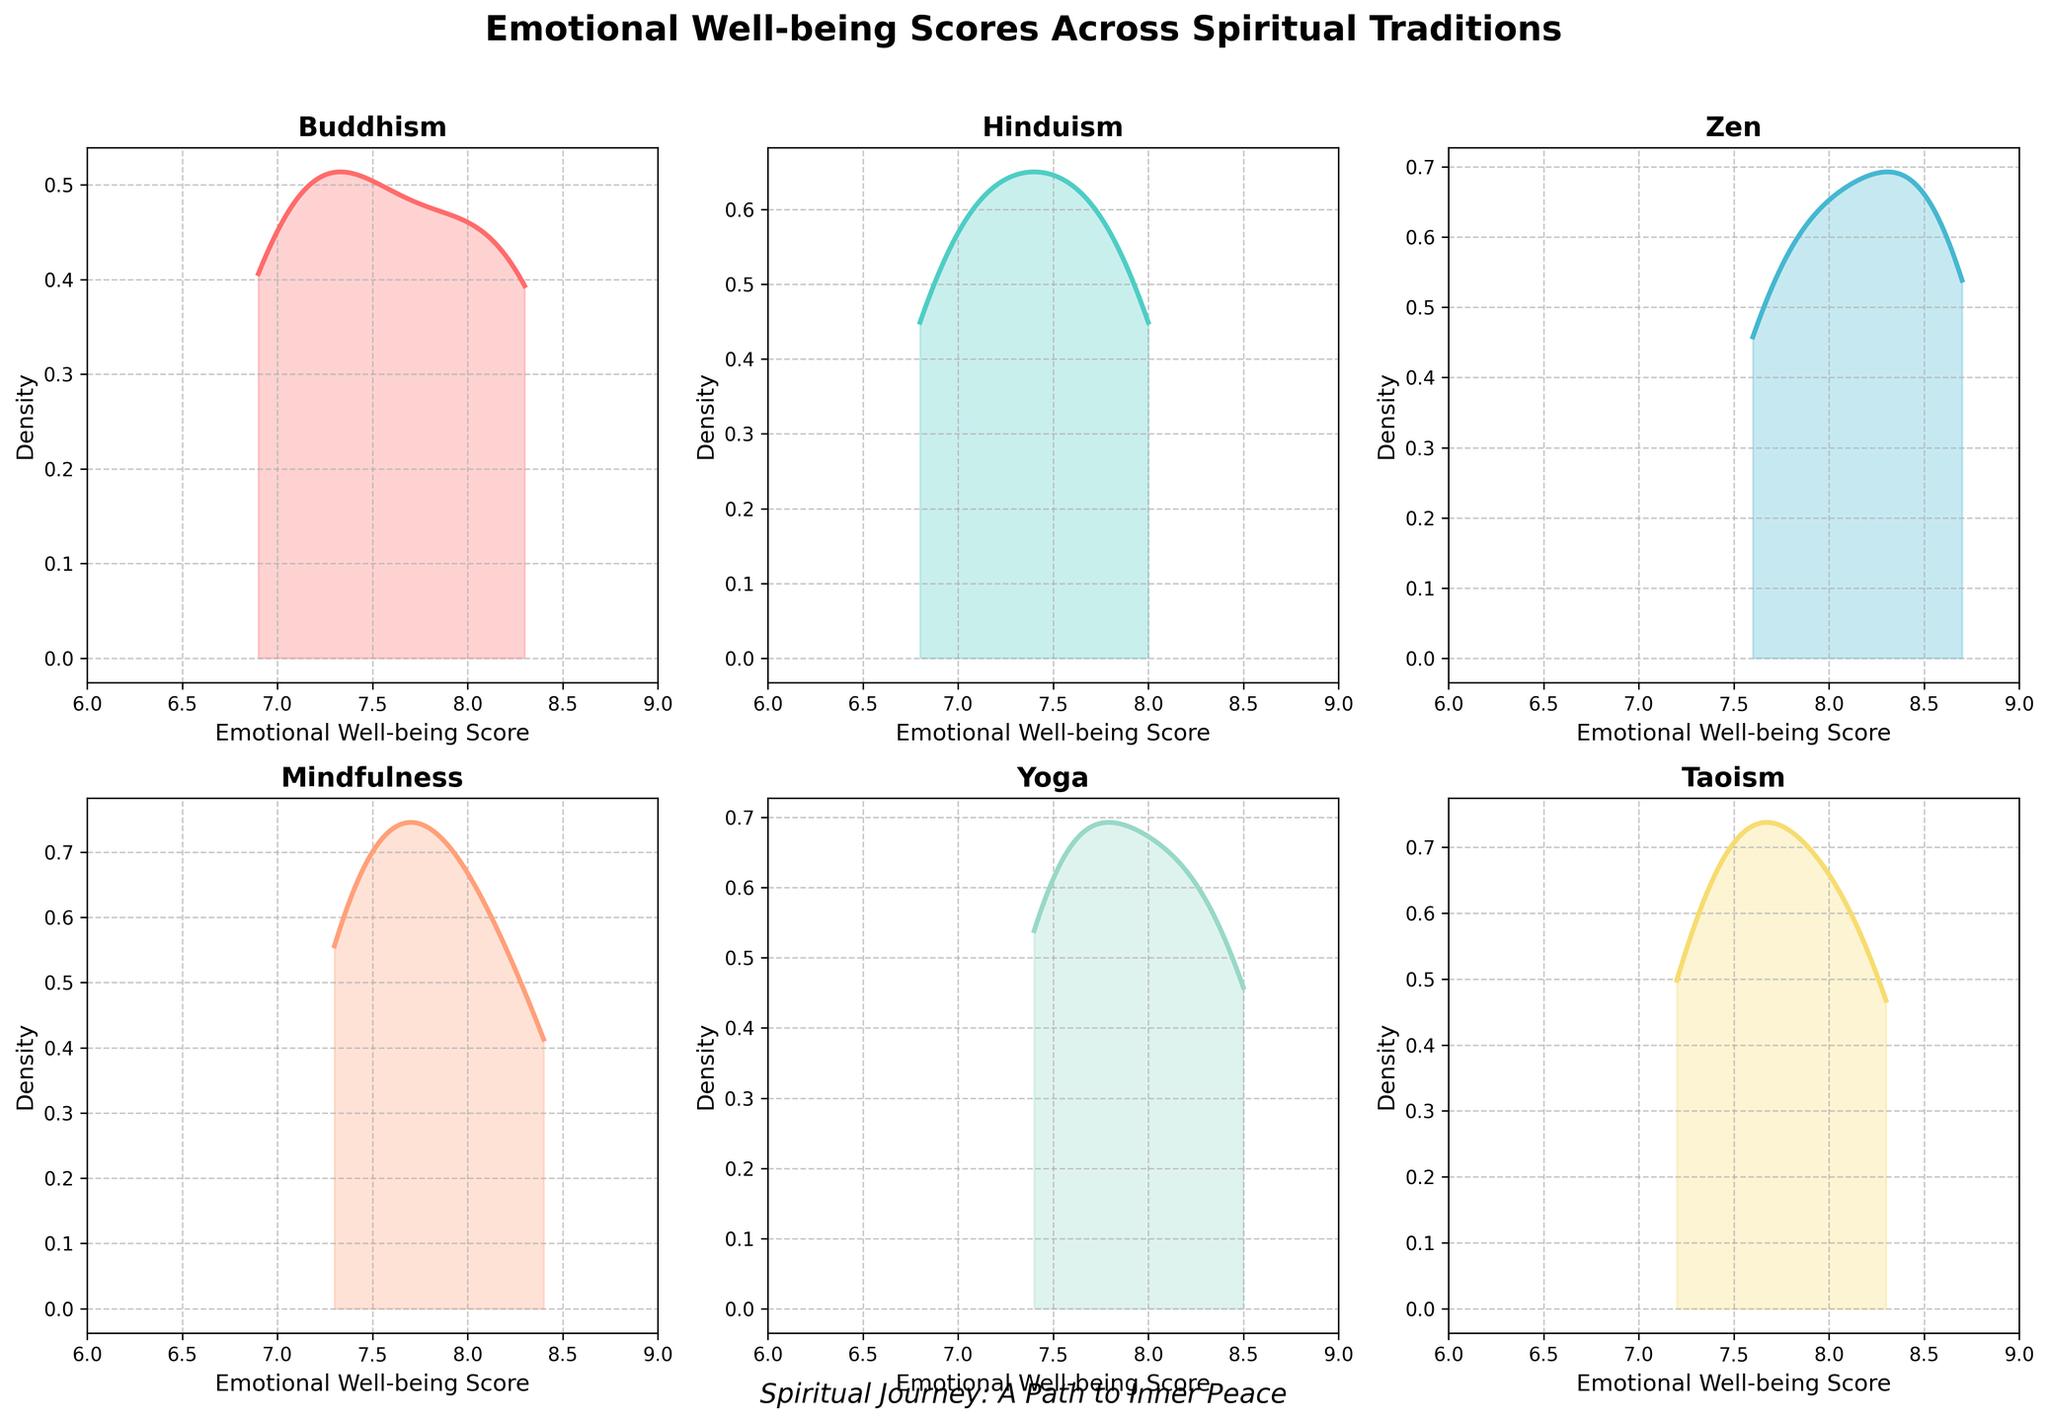What is the title of the figure? The title of the figure is typically located at the top and serves as a summary of the plot's subject. In this case, the title reads "Emotional Well-being Scores Across Spiritual Traditions."
Answer: Emotional Well-being Scores Across Spiritual Traditions Which spiritual tradition shows the widest range of emotional well-being scores? By observing the x-axis range for each subplot, we can see that each tradition has a range between approximately 6 and 9. However, the relative distribution widths can indicate the variability within those ranges. Zen and Taoism both have slightly wider distributions.
Answer: Zen and Taoism Which subplot has the highest peak in density? The height of the peak in a density plot indicates where the scores are most concentrated. By looking at all subplots, the density peak in the Zen subplot appears to be the highest.
Answer: Zen What is the primary color used in the subplot for Yoga? Each subplot has a unique color to differentiate them. The Yoga subplot uses a light pinkish color which stands out among the others.
Answer: Light pink Between Buddhism and Mindfulness, which tradition has a higher average emotional well-being score? By examining the density plots, the Buddhism and Mindfulness distributions, we see the peak for Mindfulness is closer to higher scores on the x-axis compared to Buddhism, indicating a higher average score.
Answer: Mindfulness What is the emotional well-being score range displayed on the x-axis for all traditions? Each subplot shares a common x-axis range to ensure comparability, and it is evident that they range from 6 to 9.
Answer: 6 to 9 Which tradition has the most consistently high emotional well-being scores? Consistency in this context can be interpreted by the density focusing on fewer, higher values. By observing the density plots, Zen shows high concentration around higher scores, indicating consistent high scores.
Answer: Zen What can you say about the emotional well-being scores for the Hinduism tradition based on the density plot? The density plot for Hinduism shows a peak around mid to high scores, meaning that most of the scores are moderate to high with less variation.
Answer: Moderate to high scores with less variation What is the shape of the density plot for Taoism and how does it indicate the distribution of scores? The density plot for Taoism is relatively symmetrical, indicating that emotional well-being scores are evenly distributed around the center, suggesting a balanced spread of scores.
Answer: Symmetrical, balanced spread 